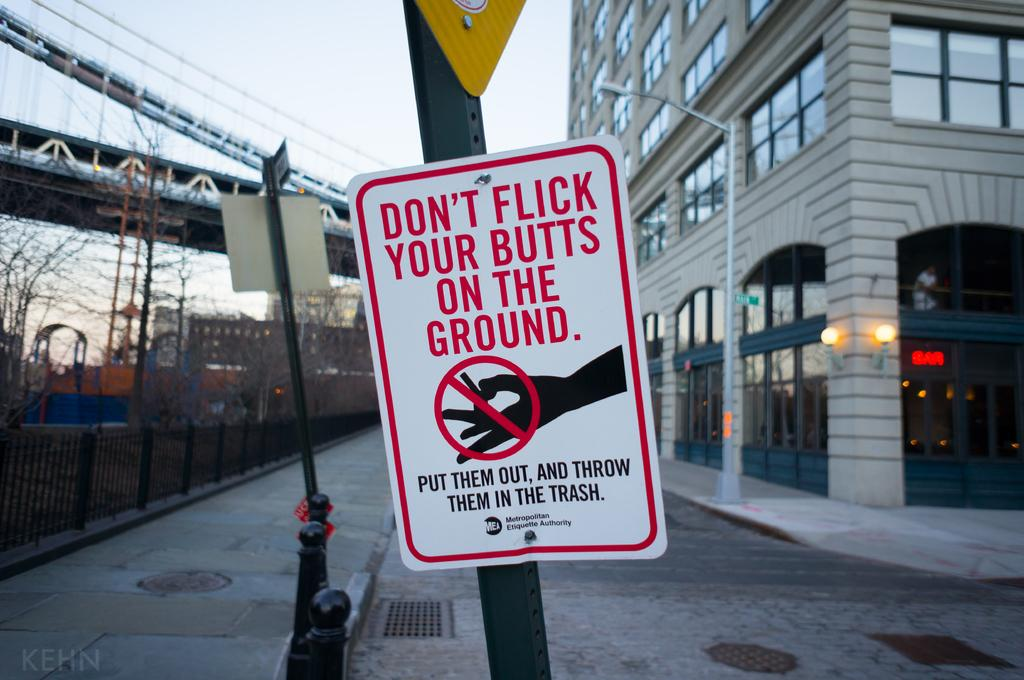Provide a one-sentence caption for the provided image. A public sign discouraging smokers from throwing cigarette butts on the ground. 